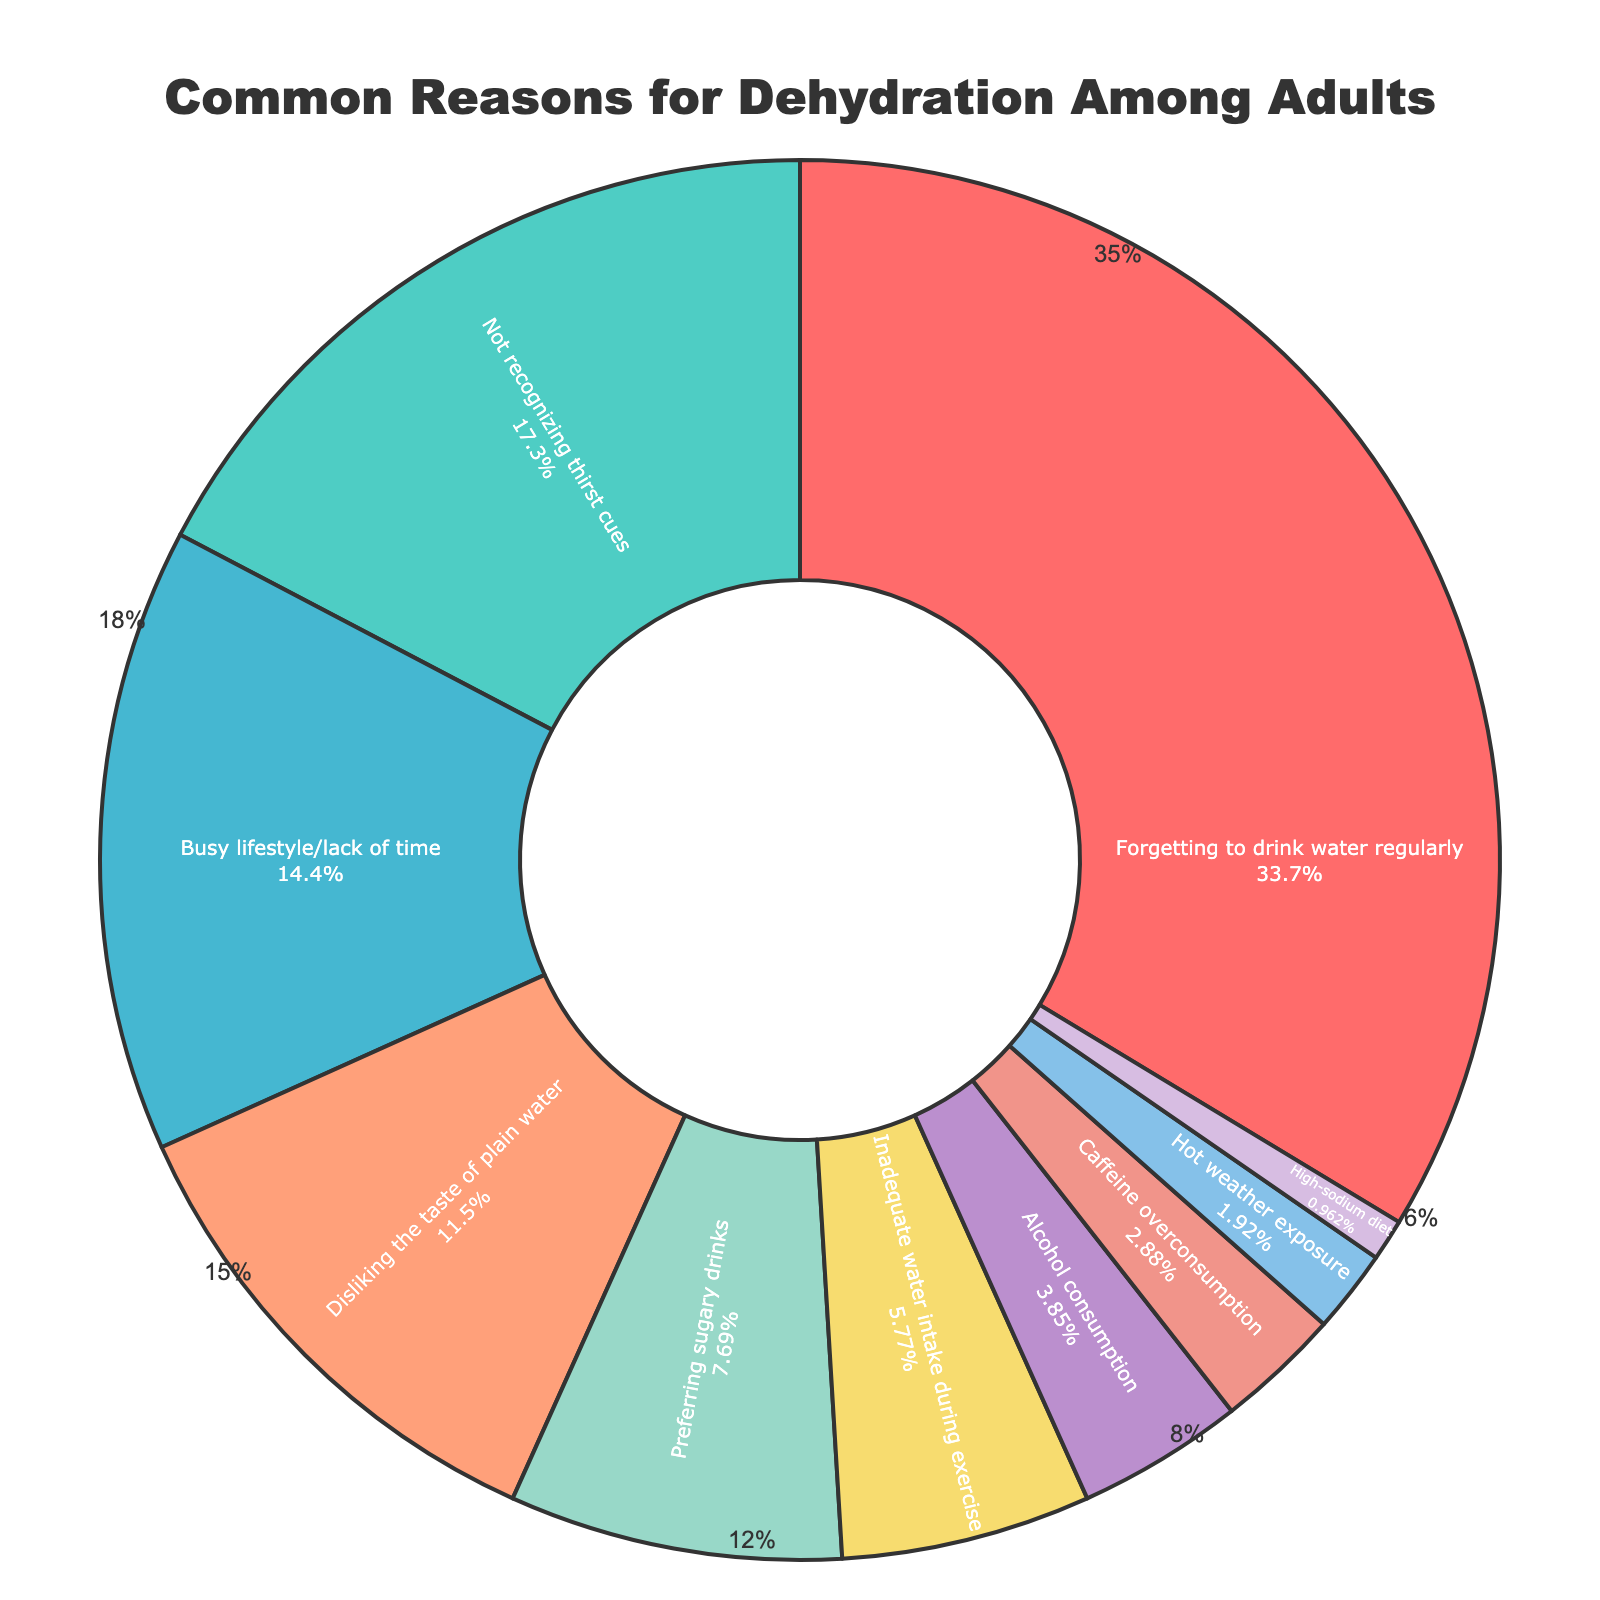what is the most common reason for dehydration among adults? The most common reason can be identified by the segment with the largest portion. According to the pie chart, "Forgetting to drink water regularly" occupies the largest portion.
Answer: Forgetting to drink water regularly How many reasons contribute more than 10% to dehydration? Add up the reasons with percentages greater than or equal to 10%. The segments are "Forgetting to drink water regularly" (35%), "Not recognizing thirst cues" (18%), "Busy lifestyle/lack of time" (15%), and "Disliking the taste of plain water" (12%), making it four reasons.
Answer: 4 What is the combined percentage of dehydration caused by "alcohol consumption" and "caffeine overconsumption"? Sum the percentages of "Alcohol consumption" (4%) and "Caffeine overconsumption" (3%). The combined percentage is 4% + 3% = 7%.
Answer: 7% Which reason has a higher percentage: "Preferring sugary drinks" or "Inadequate water intake during exercise"? Compare the percentages of "Preferring sugary drinks" (8%) and "Inadequate water intake during exercise" (6%). Since 8% is greater than 6%, "Preferring sugary drinks" has a higher percentage.
Answer: Preferring sugary drinks What is the smallest reason contributing to dehydration according to the plot? Identify the segment with the smallest percentage. The segment "High-sodium diet" has the smallest portion at 1%.
Answer: High-sodium diet Which reasons combined account for 20% of dehydration? Find combinations of segments whose sum is 20%. "Alcohol consumption" (4%) plus "Caffeine overconsumption" (3%) plus "Hot weather exposure" (2%) plus "High-sodium diet" (1%) would sum to 4% + 3% + 2% + 1% = 10%. Alternatively, "Inadequate water intake during exercise" (6%) and "Hot weather exposure" (2%) also sum up to 20% with a combination of "Preferring sugary drinks" (8%), (three 15%) totaling 20%.
Answer: Inadequate water intake during exercise and Hot weather exposure How much greater is the percentage of "Not recognizing thirst cues" compared to "Preferring sugary drinks"? Subtract the percentage of "Preferring sugary drinks" (8%) from "Not recognizing thirst cues" (18%). So, 18% - 8% = 10%.
Answer: 10% Which colored segment represents "Busy lifestyle/lack of time"? Visually identify the segment color associated with "Busy lifestyle/lack of time" which is likely based on the custom palette. It is associated with the color.
Answer: Light Red What is the cumulative percentage of the top three reasons for dehydration? Sum the percentages of the top three reasons: "Forgetting to drink water regularly" (35%), "Not recognizing thirst cues" (18%), and "Busy lifestyle/lack of time" (15%). The total is 35% + 18% + 15% = 68%.
Answer: 68% If you were to drink plain water and not sugary drinks, by how much would you reduce the risk of dehydration based on the given data? Compare the percentages, with "Preferring sugary drinks" accounting for 8%. If you would eliminate the risk factor associated with it, the percentage reduction would be 8%.
Answer: 8% 